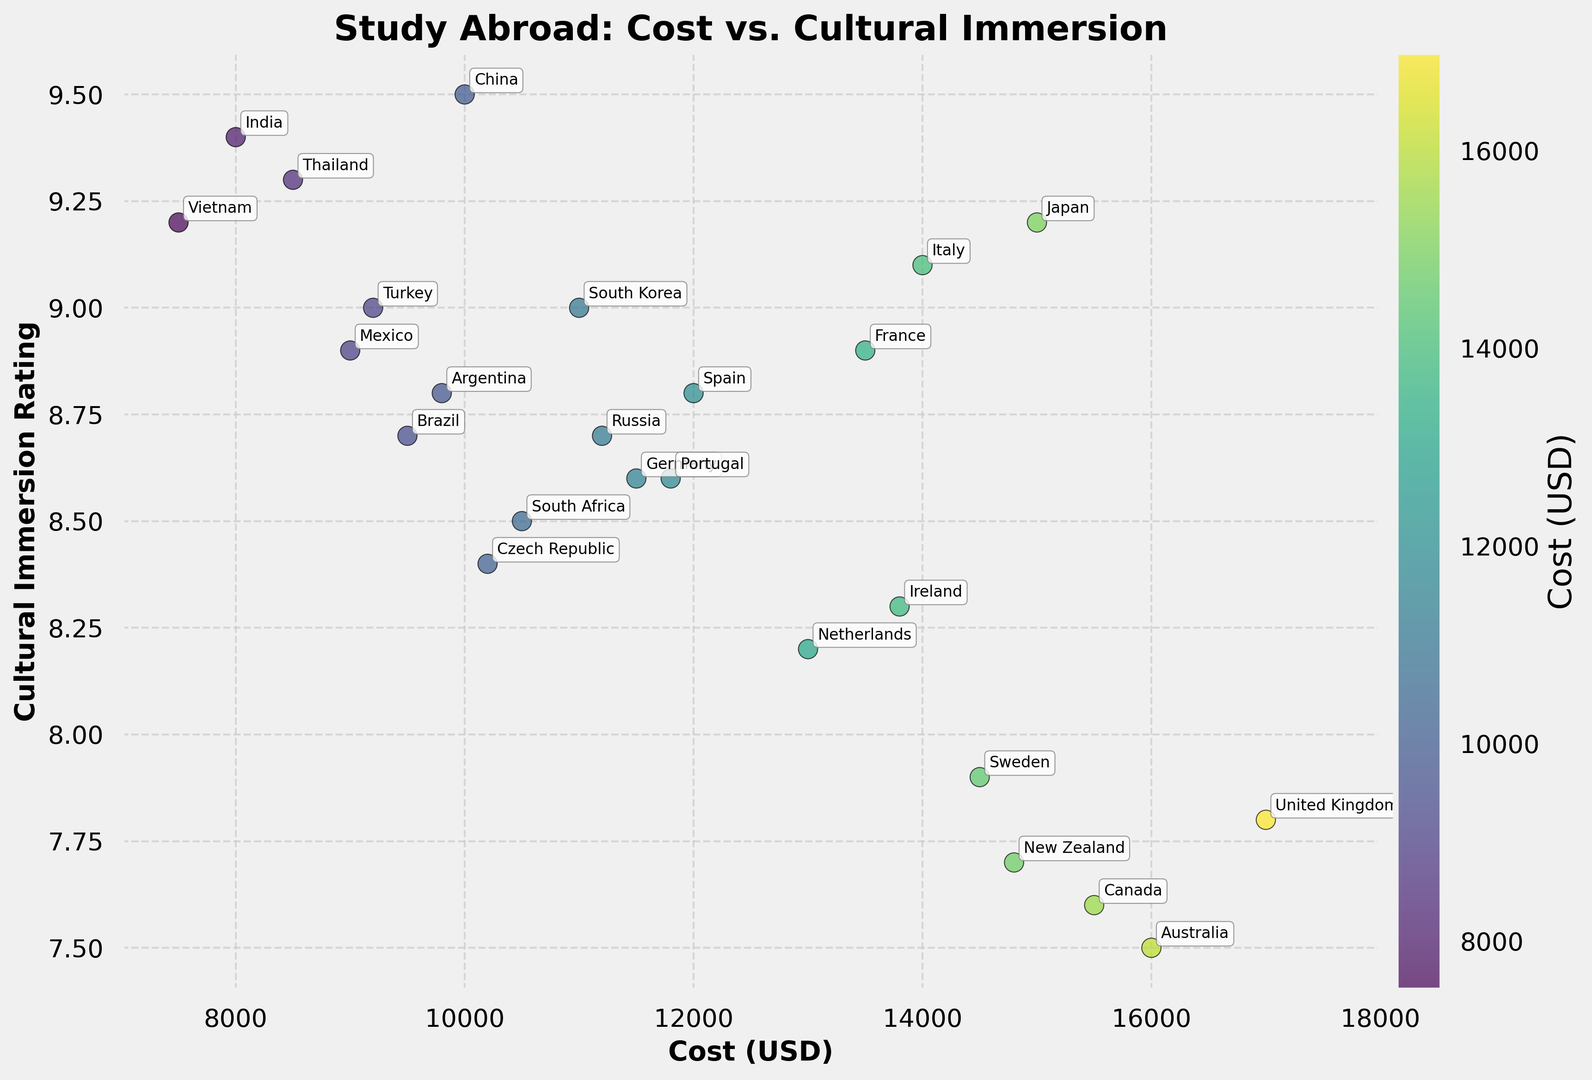What is the cost of the program with the highest cultural immersion rating? Identify the point on the scatter plot with the highest y-value (Cultural Immersion Rating). This point is for China, with a rating of 9.5. The corresponding x-value (Cost USD) is 10000.
Answer: 10000 Which destination has the lowest cultural immersion rating and what is its cost? Find the point on the scatter plot with the lowest y-value (Cultural Immersion Rating). This point is for Australia, with a rating of 7.5. The corresponding x-value (Cost USD) is 16000.
Answer: Australia, 16000 Is there a destination with a cultural immersion rating greater than 9.0 and a cost less than 10000 USD? If so, which one? Check the scatter plot for any points that satisfy both conditions: y-value (Cultural Immersion Rating) greater than 9.0 and x-value (Cost USD) less than 10000. Thailand (Rating 9.3, Cost 8500), Mexico (Rating 8.9, Cost 9000), and Vietnam (Rating 9.2, Cost 7500) fit these conditions. However, since Mexico does not satisfy cultural rating > 9, only Vietnam and Thailand fit.
Answer: Thailand, Vietnam Which two destinations have the most similar costs but different cultural immersion ratings? Look for points with x-values (Cost USD) that are very close to each other but have different y-values (Cultural Immersion Ratings). France (13500 and 8.9) and Netherlands (13000 and 8.2) are close in cost but have different cultural immersion ratings.
Answer: France, Netherlands What is the average cost for destinations with a cultural immersion rating of 9.0 or higher? Identify all points with y-values (Cultural Immersion Rating) of 9.0 or higher: Japan, China, Italy, South Korea, Thailand, Vietnam, Turkey, and India. Sum their x-values (Costs) and divide by the number of destinations: (15000 + 10000 + 14000 + 11000 + 8500 + 7500 + 9200 + 8000) / 8 = 103200 / 8 = 12900.
Answer: 12900 Which destination located has the highest cost and what is its cultural immersion rating? Find the point on the scatter plot with the highest x-value (Cost USD). This point is for the United Kingdom with a cost of 17000. The corresponding y-value (Cultural Immersion Rating) is 7.8.
Answer: United Kingdom, 7.8 How many destinations have costs between 9000 and 15000 USD? Count the number of points on the scatter plot with x-values (Cost USD) between 9000 and 15000. The destinations are Japan, Spain, France, Germany, China, Italy, South Korea, Netherlands, Thailand, Mexico, South Africa, Sweden, Argentina, Russia, Ireland, Portugal, and Czech Republic. There are 17 such destinations.
Answer: 17 How does the cost of studying in Mexico compare to that of studying in Brazil? Look at the x-values (Cost USD) for Mexico and Brazil. Mexico has a cost of 9000 while Brazil has a cost of 9500. Mexico is cheaper than Brazil.
Answer: Mexico is cheaper than Brazil What is the range of cultural immersion ratings for programs that cost more than 14000 USD? Identify the y-values (Cultural Immersion Ratings) for points with x-values (Cost USD) greater than 14000: Japan, Australia, United Kingdom, Canada, Sweden, New Zealand. This gives ratings 9.2, 7.5, 7.8, 7.6, 7.9, 7.7. The range is the difference between the maximum and minimum values: 9.2 - 7.5 = 1.7.
Answer: 1.7 If you had a budget ceiling of 10000 USD, which destinations would be within your reach and what are their cultural immersion ratings? Identify points with x-values (Cost USD) less than or equal to 10000. These are Brazil (9500, 8.7), China (10000, 9.5), Mexico (9000, 8.9), Thailand (8500, 9.3), Vietnam (7500, 9.2), Argentina (9800, 8.8), and India (8000, 9.4). The corresponding ratings are 8.7, 9.5, 8.9, 9.3, 9.2, 8.8, and 9.4 respectively.
Answer: Brazil, China, Mexico, Thailand, Vietnam, Argentina, India 